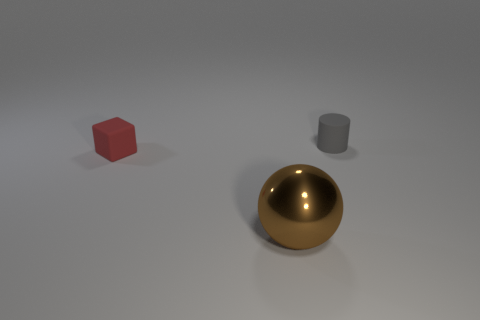Add 3 tiny matte cylinders. How many objects exist? 6 Subtract all cubes. How many objects are left? 2 Subtract all large things. Subtract all tiny rubber cylinders. How many objects are left? 1 Add 2 big objects. How many big objects are left? 3 Add 3 large shiny balls. How many large shiny balls exist? 4 Subtract 0 green cylinders. How many objects are left? 3 